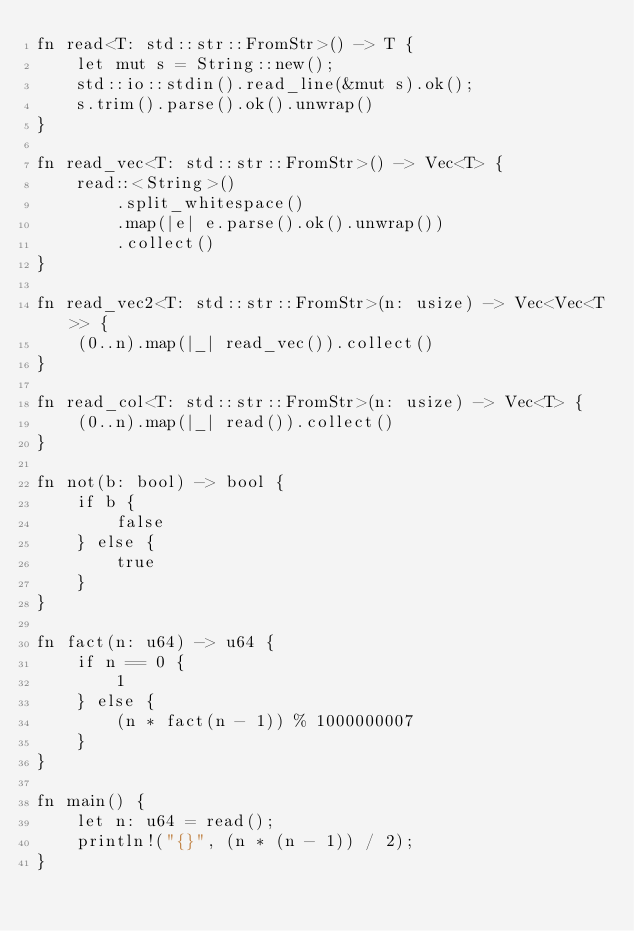<code> <loc_0><loc_0><loc_500><loc_500><_Rust_>fn read<T: std::str::FromStr>() -> T {
    let mut s = String::new();
    std::io::stdin().read_line(&mut s).ok();
    s.trim().parse().ok().unwrap()
}

fn read_vec<T: std::str::FromStr>() -> Vec<T> {
    read::<String>()
        .split_whitespace()
        .map(|e| e.parse().ok().unwrap())
        .collect()
}

fn read_vec2<T: std::str::FromStr>(n: usize) -> Vec<Vec<T>> {
    (0..n).map(|_| read_vec()).collect()
}

fn read_col<T: std::str::FromStr>(n: usize) -> Vec<T> {
    (0..n).map(|_| read()).collect()
}

fn not(b: bool) -> bool {
    if b {
        false
    } else {
        true
    }
}

fn fact(n: u64) -> u64 {
    if n == 0 {
        1
    } else {
        (n * fact(n - 1)) % 1000000007
    }
}

fn main() {
    let n: u64 = read();
    println!("{}", (n * (n - 1)) / 2);
}
</code> 